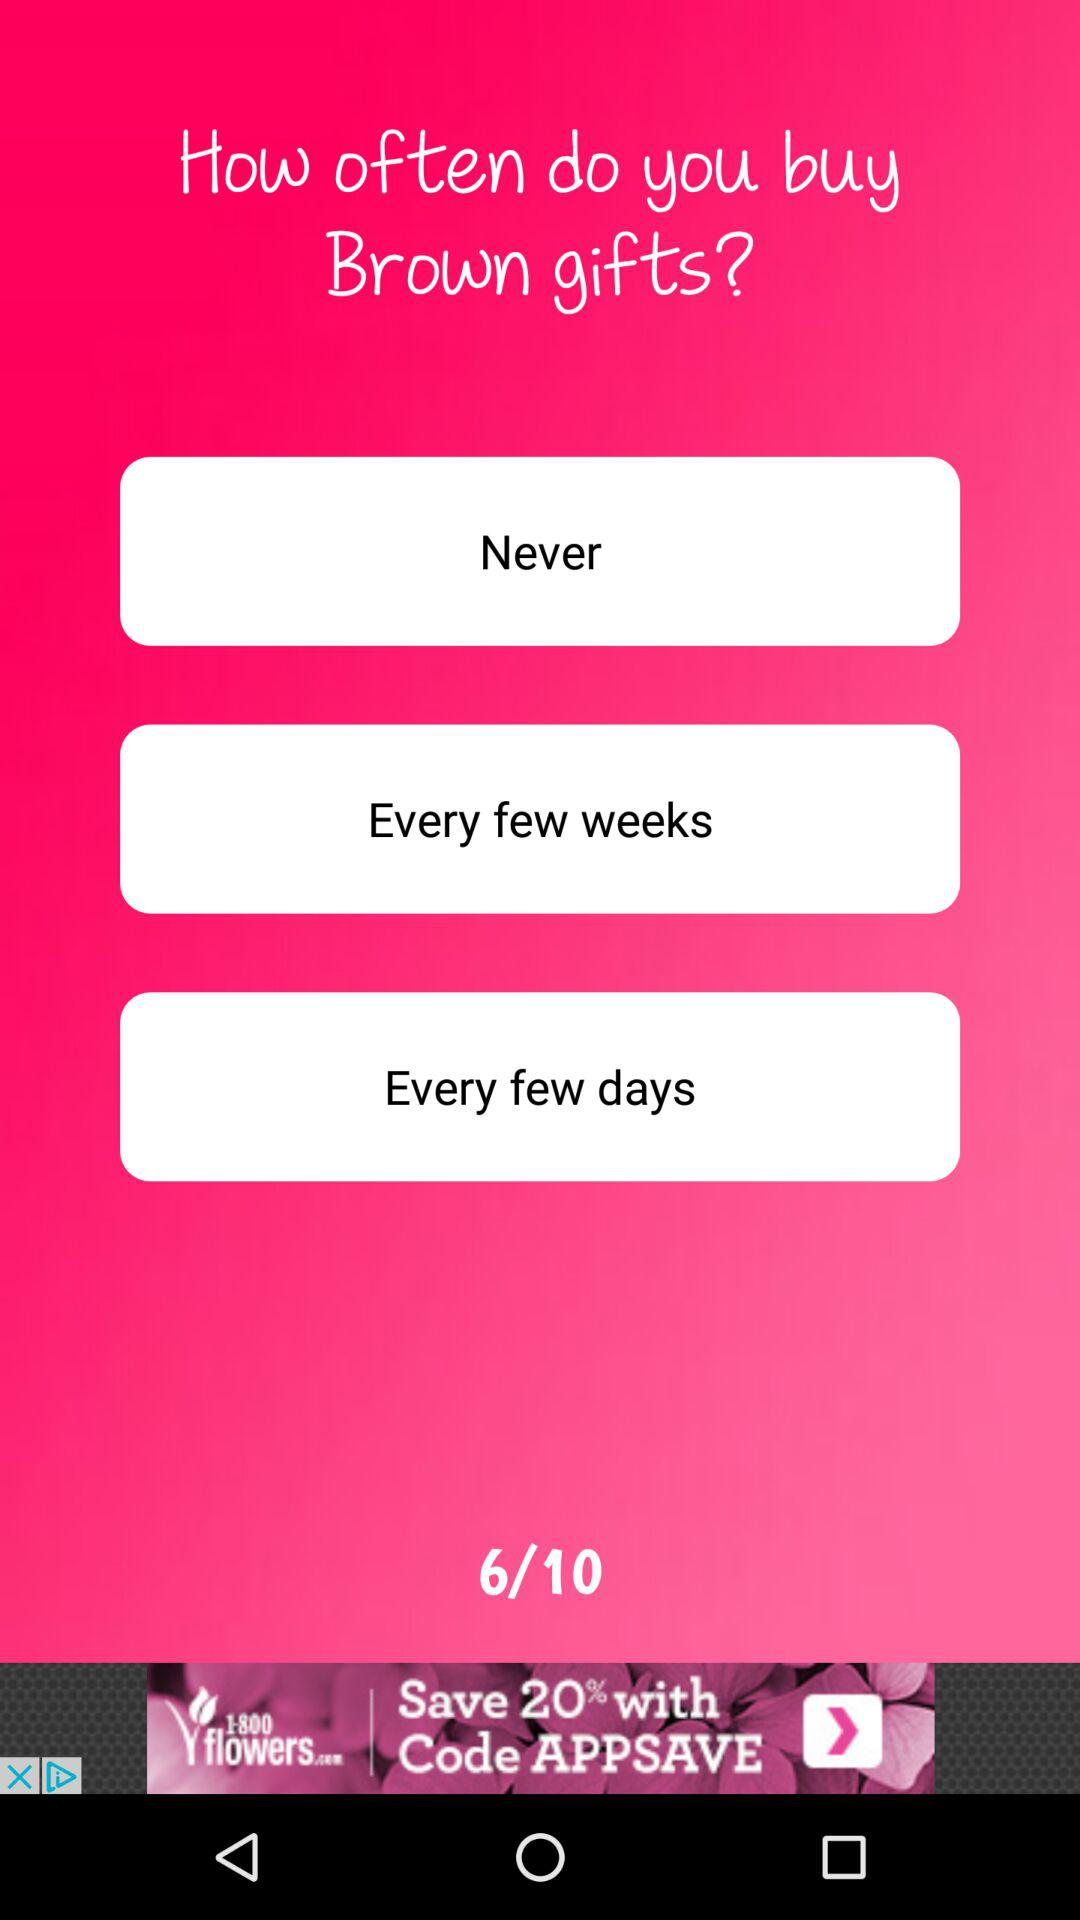At which question number are we right now? Right now, you are at the sixth question. 